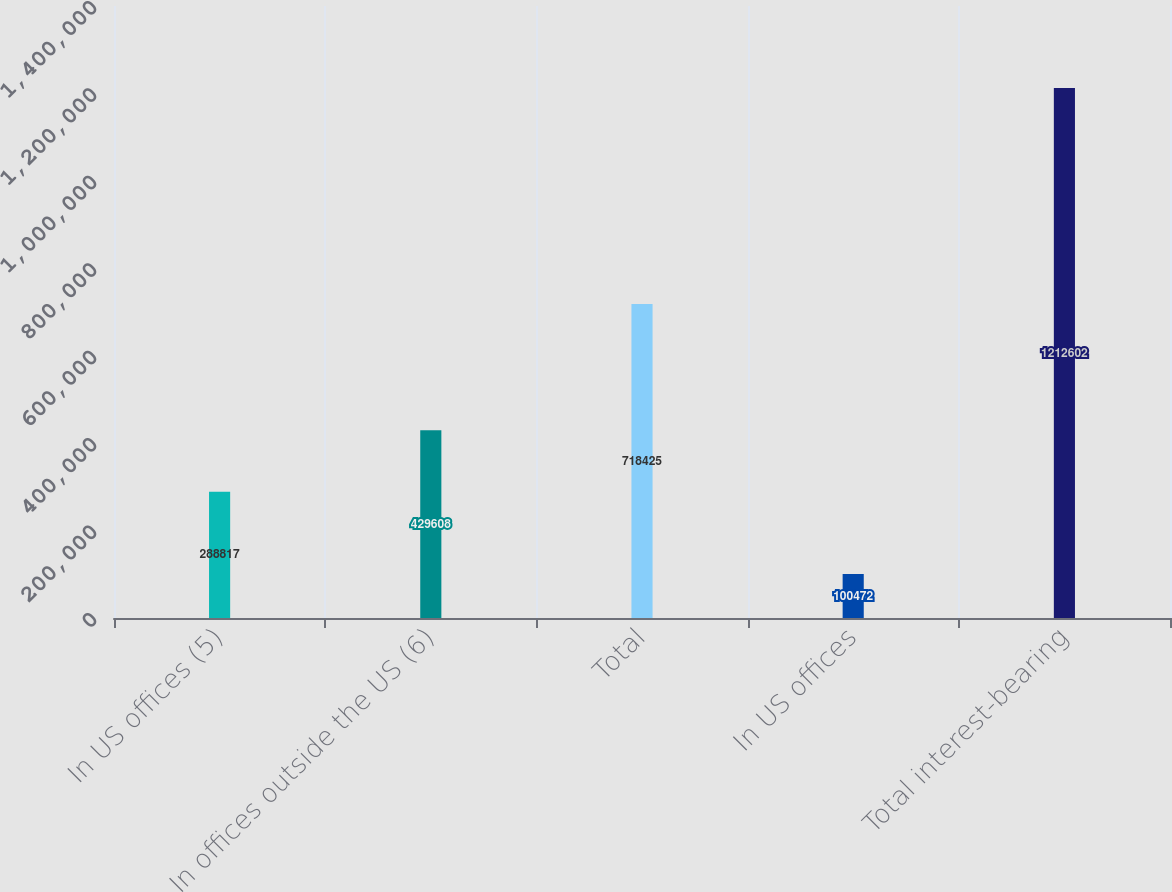<chart> <loc_0><loc_0><loc_500><loc_500><bar_chart><fcel>In US offices (5)<fcel>In offices outside the US (6)<fcel>Total<fcel>In US offices<fcel>Total interest-bearing<nl><fcel>288817<fcel>429608<fcel>718425<fcel>100472<fcel>1.2126e+06<nl></chart> 